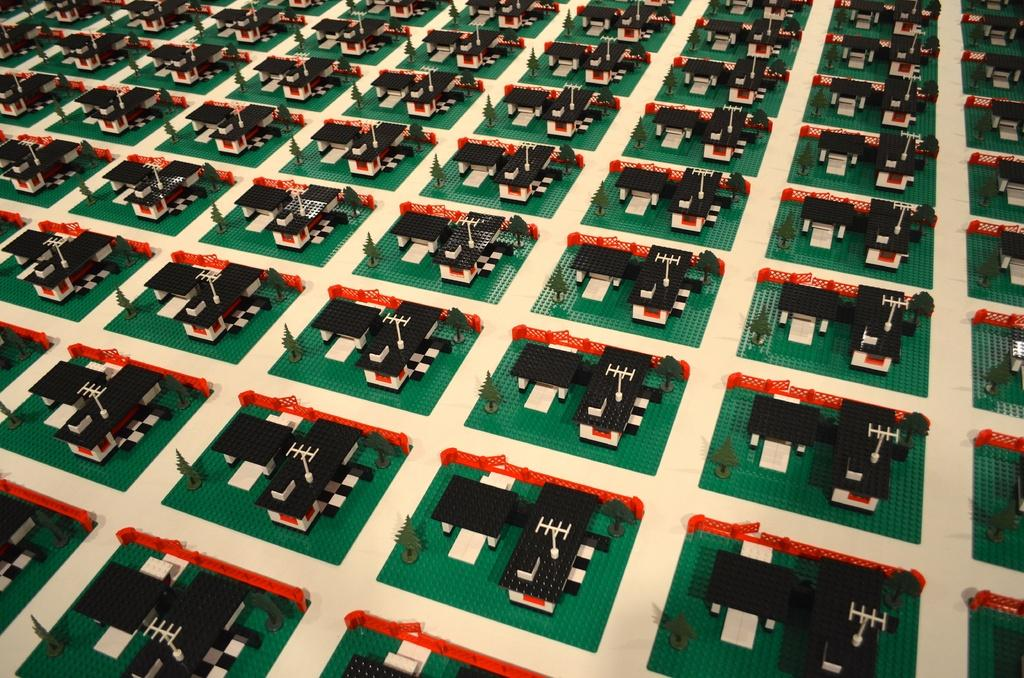What type of design can be seen in the image? The image contains a carpet design. Can you describe the pattern or style of the carpet design? Unfortunately, the provided facts do not include a description of the pattern or style of the carpet design. What colors are used in the carpet design? The provided facts do not specify the colors used in the carpet design. How does the surprise appear in the image? There is no surprise present in the image; it only contains a carpet design. What type of milk is being poured onto the carpet design in the image? There is no milk present in the image; it only contains a carpet design. 